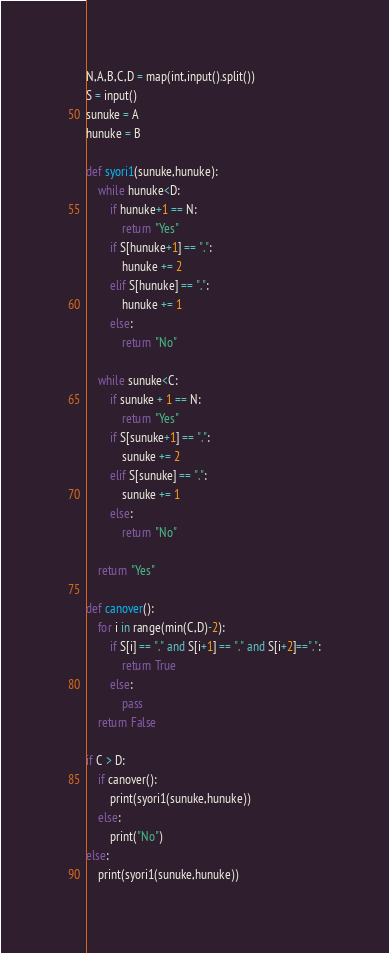Convert code to text. <code><loc_0><loc_0><loc_500><loc_500><_Python_>N,A,B,C,D = map(int,input().split())
S = input()
sunuke = A
hunuke = B

def syori1(sunuke,hunuke):
    while hunuke<D:
        if hunuke+1 == N:
            return "Yes"
        if S[hunuke+1] == ".":
            hunuke += 2
        elif S[hunuke] == ".":
            hunuke += 1
        else:
            return "No"
    
    while sunuke<C:
        if sunuke + 1 == N:
            return "Yes"
        if S[sunuke+1] == ".":
            sunuke += 2
        elif S[sunuke] == ".":
            sunuke += 1
        else:
            return "No"
    
    return "Yes"

def canover():
    for i in range(min(C,D)-2):
        if S[i] == "." and S[i+1] == "." and S[i+2]==".":
            return True
        else:
            pass
    return False

if C > D:
    if canover():
        print(syori1(sunuke,hunuke))
    else:
        print("No")
else:
    print(syori1(sunuke,hunuke))</code> 